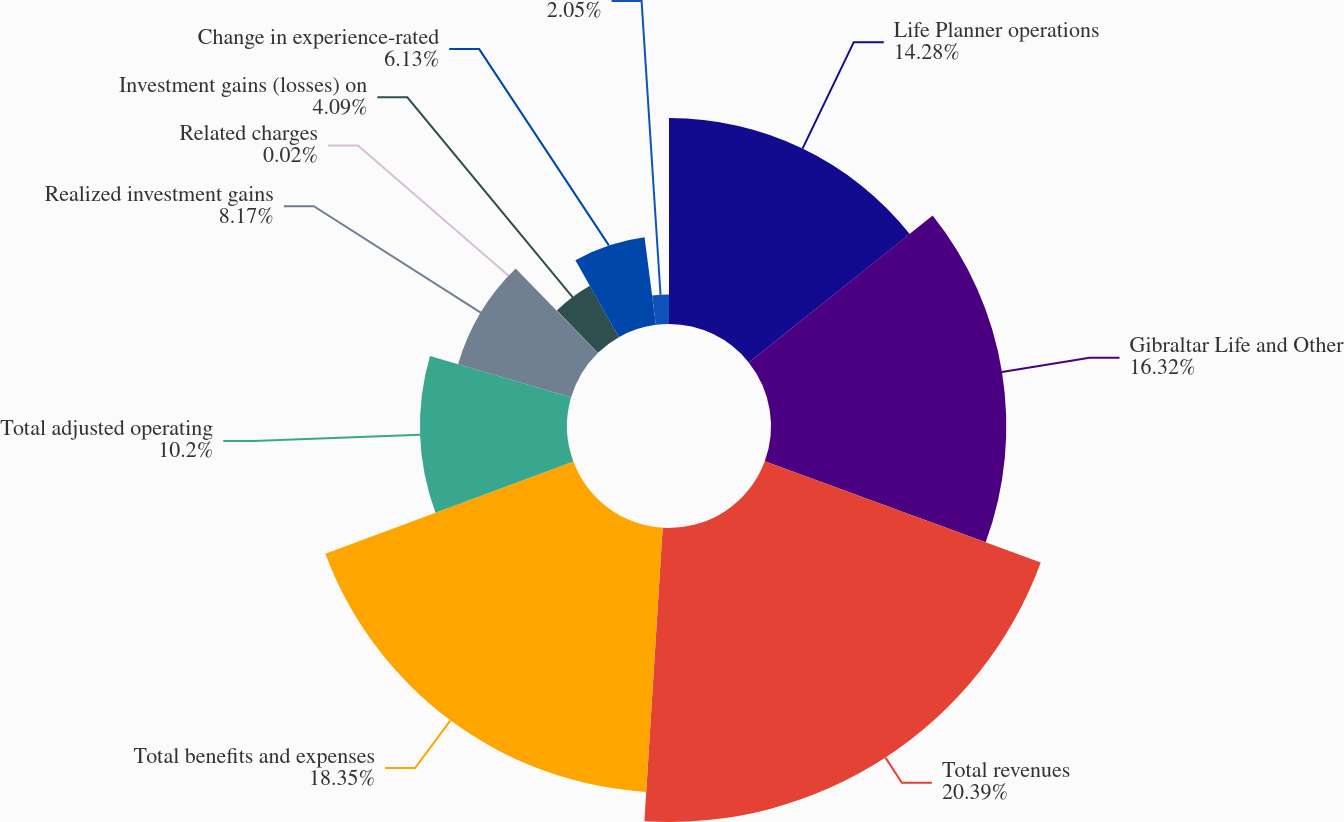<chart> <loc_0><loc_0><loc_500><loc_500><pie_chart><fcel>Life Planner operations<fcel>Gibraltar Life and Other<fcel>Total revenues<fcel>Total benefits and expenses<fcel>Total adjusted operating<fcel>Realized investment gains<fcel>Related charges<fcel>Investment gains (losses) on<fcel>Change in experience-rated<fcel>Unnamed: 9<nl><fcel>14.28%<fcel>16.32%<fcel>20.39%<fcel>18.35%<fcel>10.2%<fcel>8.17%<fcel>0.02%<fcel>4.09%<fcel>6.13%<fcel>2.05%<nl></chart> 